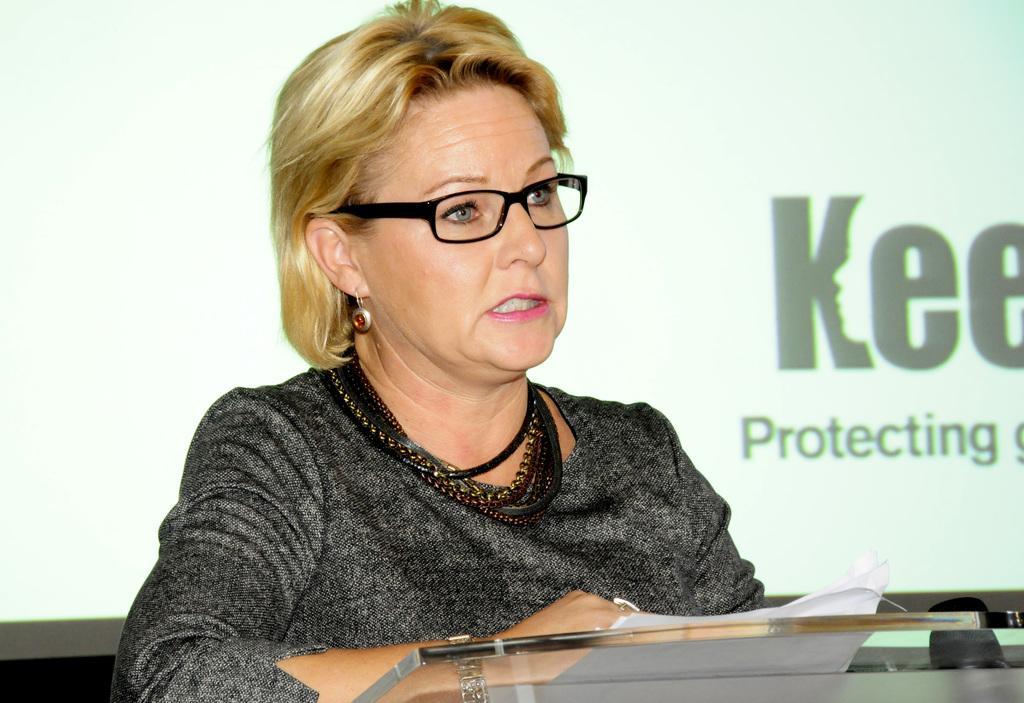Describe this image in one or two sentences. In this image I can see a woman visible in front of a glass table , in the background might be the wall, on the wall there is a text. 